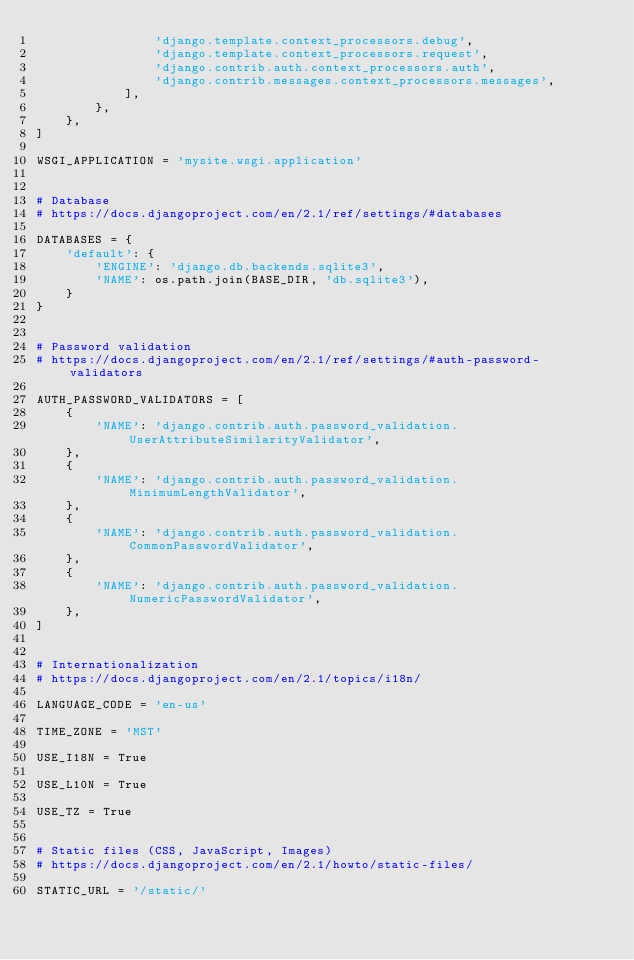Convert code to text. <code><loc_0><loc_0><loc_500><loc_500><_Python_>                'django.template.context_processors.debug',
                'django.template.context_processors.request',
                'django.contrib.auth.context_processors.auth',
                'django.contrib.messages.context_processors.messages',
            ],
        },
    },
]

WSGI_APPLICATION = 'mysite.wsgi.application'


# Database
# https://docs.djangoproject.com/en/2.1/ref/settings/#databases

DATABASES = {
    'default': {
        'ENGINE': 'django.db.backends.sqlite3',
        'NAME': os.path.join(BASE_DIR, 'db.sqlite3'),
    }
}


# Password validation
# https://docs.djangoproject.com/en/2.1/ref/settings/#auth-password-validators

AUTH_PASSWORD_VALIDATORS = [
    {
        'NAME': 'django.contrib.auth.password_validation.UserAttributeSimilarityValidator',
    },
    {
        'NAME': 'django.contrib.auth.password_validation.MinimumLengthValidator',
    },
    {
        'NAME': 'django.contrib.auth.password_validation.CommonPasswordValidator',
    },
    {
        'NAME': 'django.contrib.auth.password_validation.NumericPasswordValidator',
    },
]


# Internationalization
# https://docs.djangoproject.com/en/2.1/topics/i18n/

LANGUAGE_CODE = 'en-us'

TIME_ZONE = 'MST'

USE_I18N = True

USE_L10N = True

USE_TZ = True


# Static files (CSS, JavaScript, Images)
# https://docs.djangoproject.com/en/2.1/howto/static-files/

STATIC_URL = '/static/'
</code> 